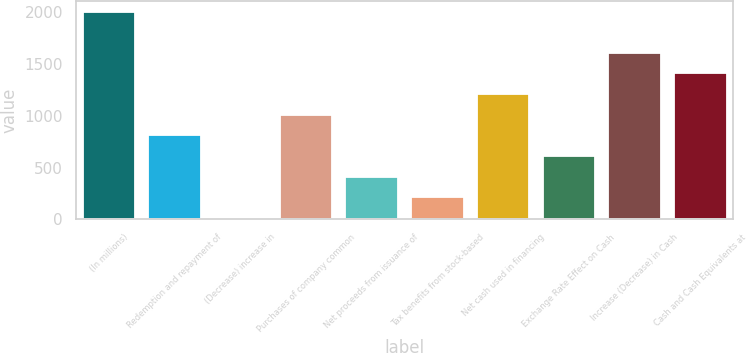Convert chart. <chart><loc_0><loc_0><loc_500><loc_500><bar_chart><fcel>(In millions)<fcel>Redemption and repayment of<fcel>(Decrease) increase in<fcel>Purchases of company common<fcel>Net proceeds from issuance of<fcel>Tax benefits from stock-based<fcel>Net cash used in financing<fcel>Exchange Rate Effect on Cash<fcel>Increase (Decrease) in Cash<fcel>Cash and Cash Equivalents at<nl><fcel>2008<fcel>812.44<fcel>15.4<fcel>1011.7<fcel>413.92<fcel>214.66<fcel>1210.96<fcel>613.18<fcel>1609.48<fcel>1410.22<nl></chart> 